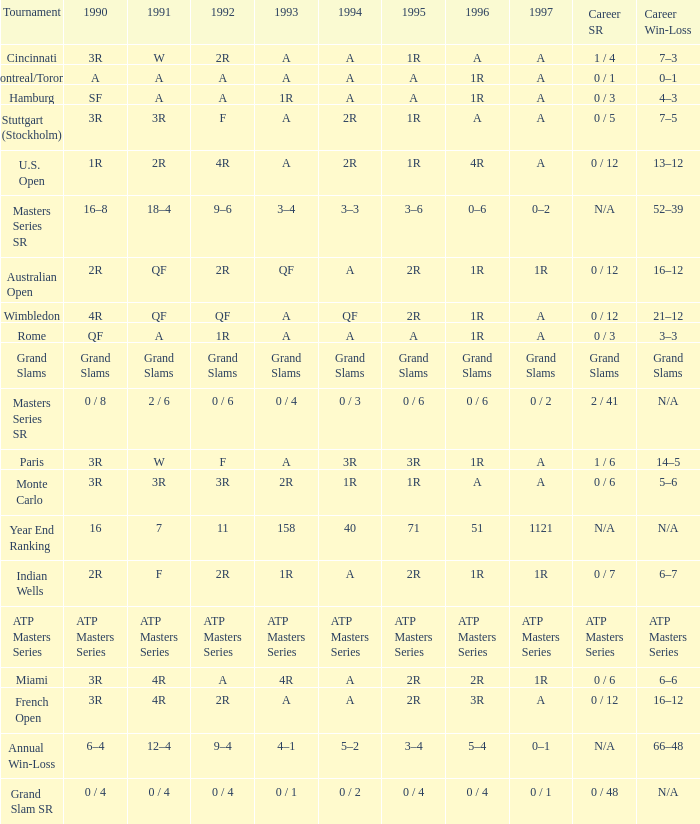What is 1996, when 1992 is "ATP Masters Series"? ATP Masters Series. 